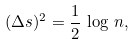<formula> <loc_0><loc_0><loc_500><loc_500>( \Delta s ) ^ { 2 } = \frac { 1 } { 2 } \, \log \, n ,</formula> 